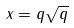<formula> <loc_0><loc_0><loc_500><loc_500>x = q \sqrt { q }</formula> 